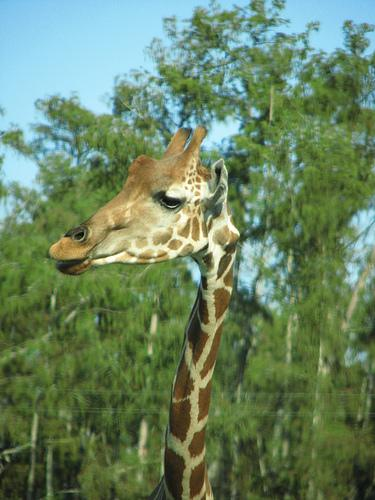Question: what is the animal shown?
Choices:
A. Elephant.
B. Giraffe.
C. A horse.
D. A cow.
Answer with the letter. Answer: B Question: where is this taken?
Choices:
A. Zoo.
B. The beach.
C. A bar.
D. A museum.
Answer with the letter. Answer: A Question: how many giraffe are shown?
Choices:
A. 2.
B. 1.
C. 3.
D. 4.
Answer with the letter. Answer: B Question: how many people are in the photo?
Choices:
A. 1.
B. 2.
C. 3.
D. 0.
Answer with the letter. Answer: D 